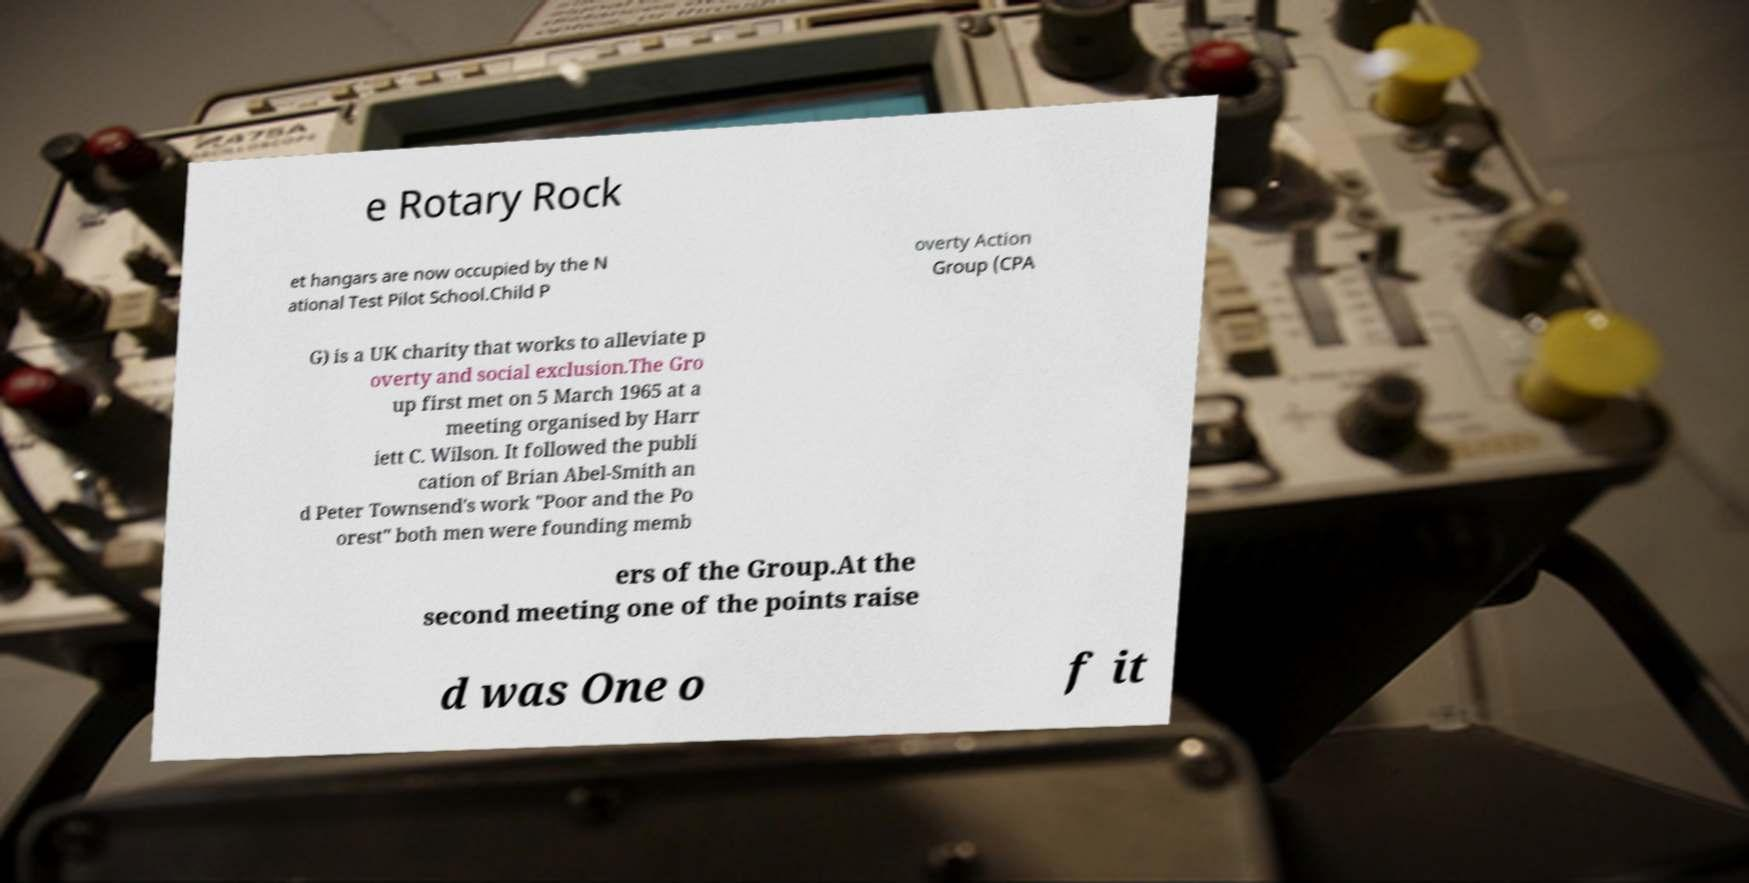Please read and relay the text visible in this image. What does it say? e Rotary Rock et hangars are now occupied by the N ational Test Pilot School.Child P overty Action Group (CPA G) is a UK charity that works to alleviate p overty and social exclusion.The Gro up first met on 5 March 1965 at a meeting organised by Harr iett C. Wilson. It followed the publi cation of Brian Abel-Smith an d Peter Townsend's work "Poor and the Po orest" both men were founding memb ers of the Group.At the second meeting one of the points raise d was One o f it 